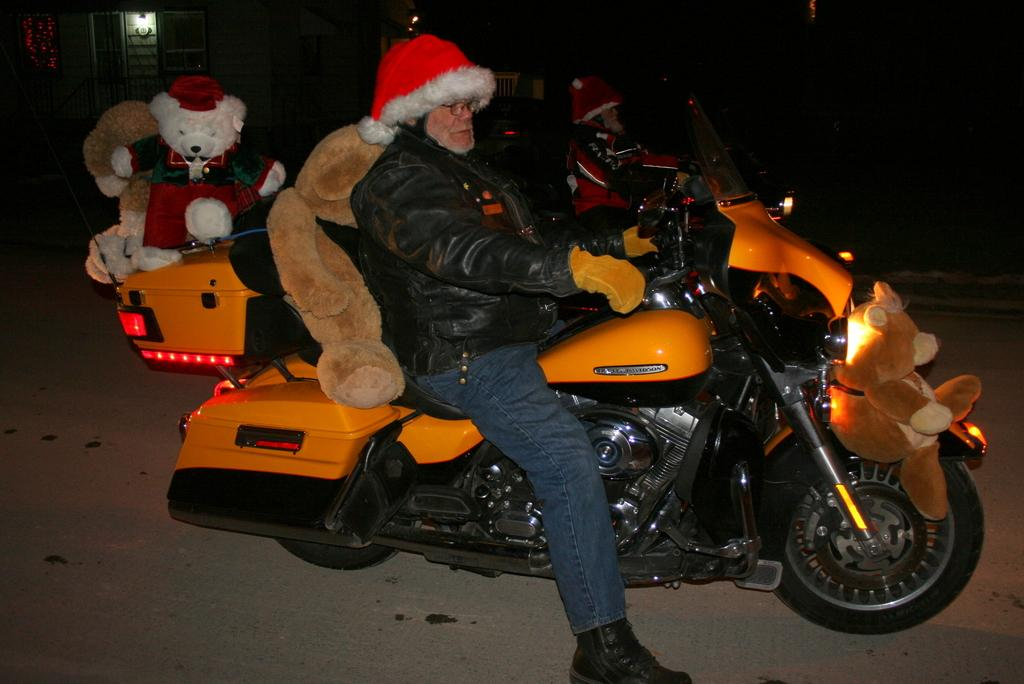How many people are in the image? There are two people in the image. What are the people doing in the image? The people are on their bikes. Can you describe anything in the background of the image? Yes, there is a soft toy visible in the background of the image. What type of cave can be seen in the image? There is no cave present in the image. 